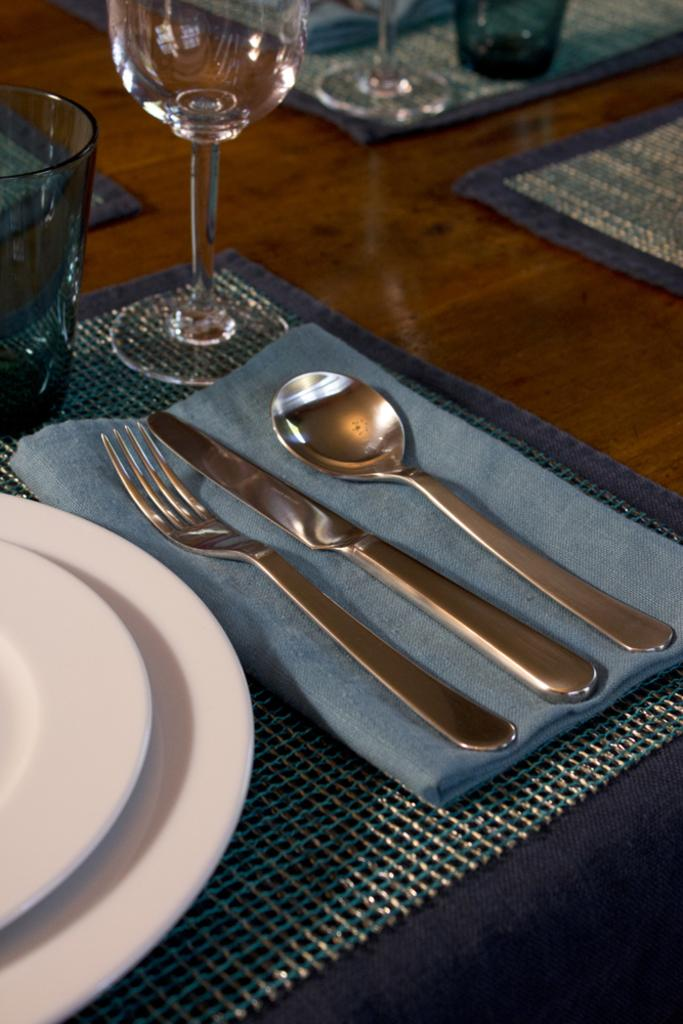What type of utensils are visible in the image? There is a fork, a knife, and a spoon in the image. What type of tableware is present in the image? There are glasses and plates in the image. What reward is being given to the planes in the image? There are no planes present in the image, so there is no reward being given to them. 